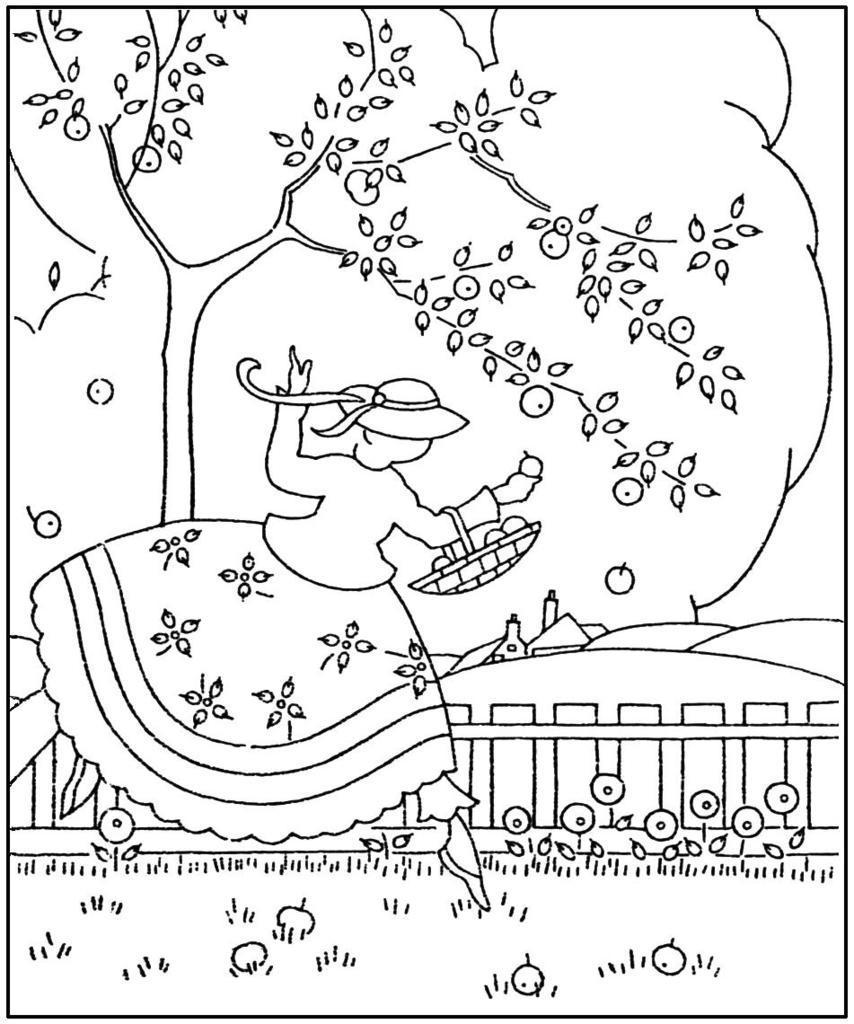Please provide a concise description of this image. In this picture I can see the cartoon image. In that there is a woman who is holding a fruit basket and standing near to the wooden fencing and trees. At the bottom it might be the glass. 